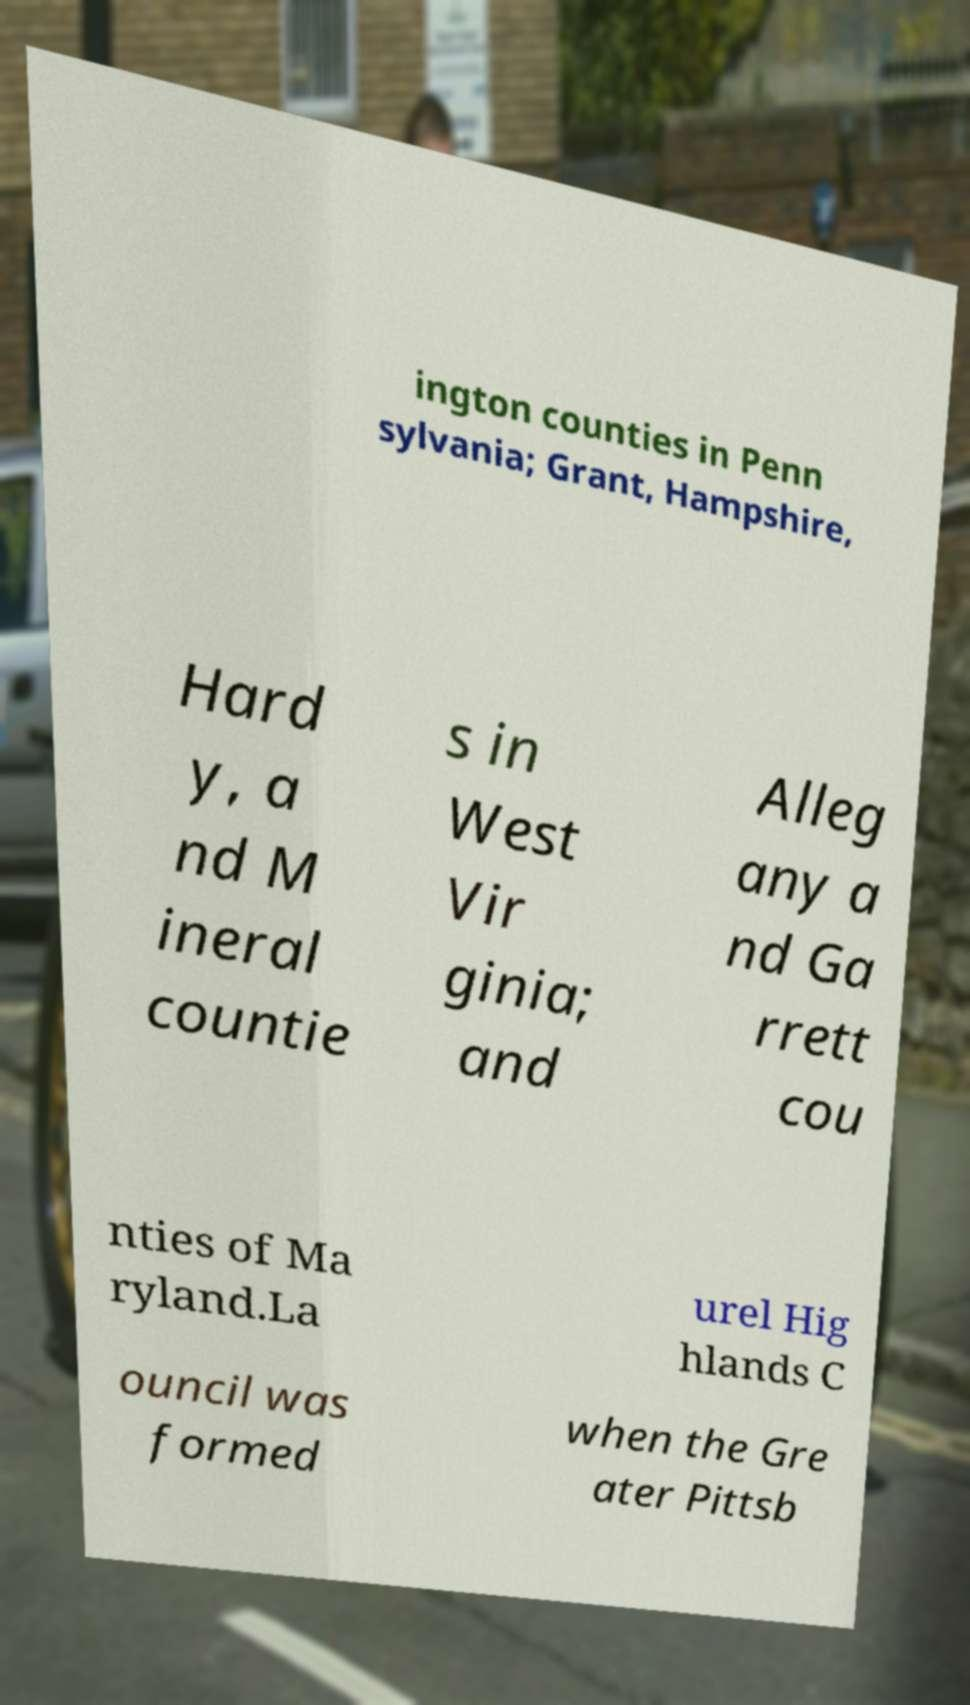Can you read and provide the text displayed in the image?This photo seems to have some interesting text. Can you extract and type it out for me? ington counties in Penn sylvania; Grant, Hampshire, Hard y, a nd M ineral countie s in West Vir ginia; and Alleg any a nd Ga rrett cou nties of Ma ryland.La urel Hig hlands C ouncil was formed when the Gre ater Pittsb 